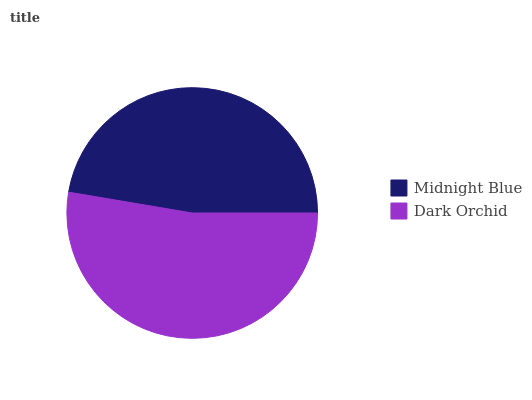Is Midnight Blue the minimum?
Answer yes or no. Yes. Is Dark Orchid the maximum?
Answer yes or no. Yes. Is Dark Orchid the minimum?
Answer yes or no. No. Is Dark Orchid greater than Midnight Blue?
Answer yes or no. Yes. Is Midnight Blue less than Dark Orchid?
Answer yes or no. Yes. Is Midnight Blue greater than Dark Orchid?
Answer yes or no. No. Is Dark Orchid less than Midnight Blue?
Answer yes or no. No. Is Dark Orchid the high median?
Answer yes or no. Yes. Is Midnight Blue the low median?
Answer yes or no. Yes. Is Midnight Blue the high median?
Answer yes or no. No. Is Dark Orchid the low median?
Answer yes or no. No. 